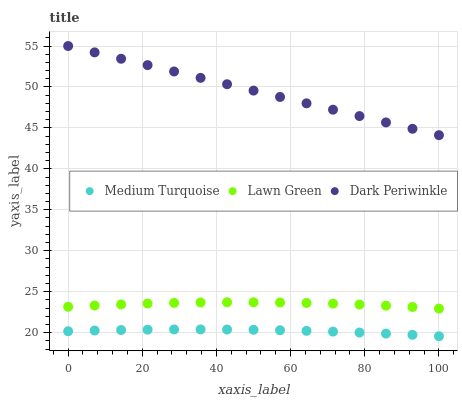Does Medium Turquoise have the minimum area under the curve?
Answer yes or no. Yes. Does Dark Periwinkle have the maximum area under the curve?
Answer yes or no. Yes. Does Dark Periwinkle have the minimum area under the curve?
Answer yes or no. No. Does Medium Turquoise have the maximum area under the curve?
Answer yes or no. No. Is Dark Periwinkle the smoothest?
Answer yes or no. Yes. Is Lawn Green the roughest?
Answer yes or no. Yes. Is Medium Turquoise the smoothest?
Answer yes or no. No. Is Medium Turquoise the roughest?
Answer yes or no. No. Does Medium Turquoise have the lowest value?
Answer yes or no. Yes. Does Dark Periwinkle have the lowest value?
Answer yes or no. No. Does Dark Periwinkle have the highest value?
Answer yes or no. Yes. Does Medium Turquoise have the highest value?
Answer yes or no. No. Is Medium Turquoise less than Dark Periwinkle?
Answer yes or no. Yes. Is Lawn Green greater than Medium Turquoise?
Answer yes or no. Yes. Does Medium Turquoise intersect Dark Periwinkle?
Answer yes or no. No. 